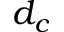<formula> <loc_0><loc_0><loc_500><loc_500>d _ { c }</formula> 